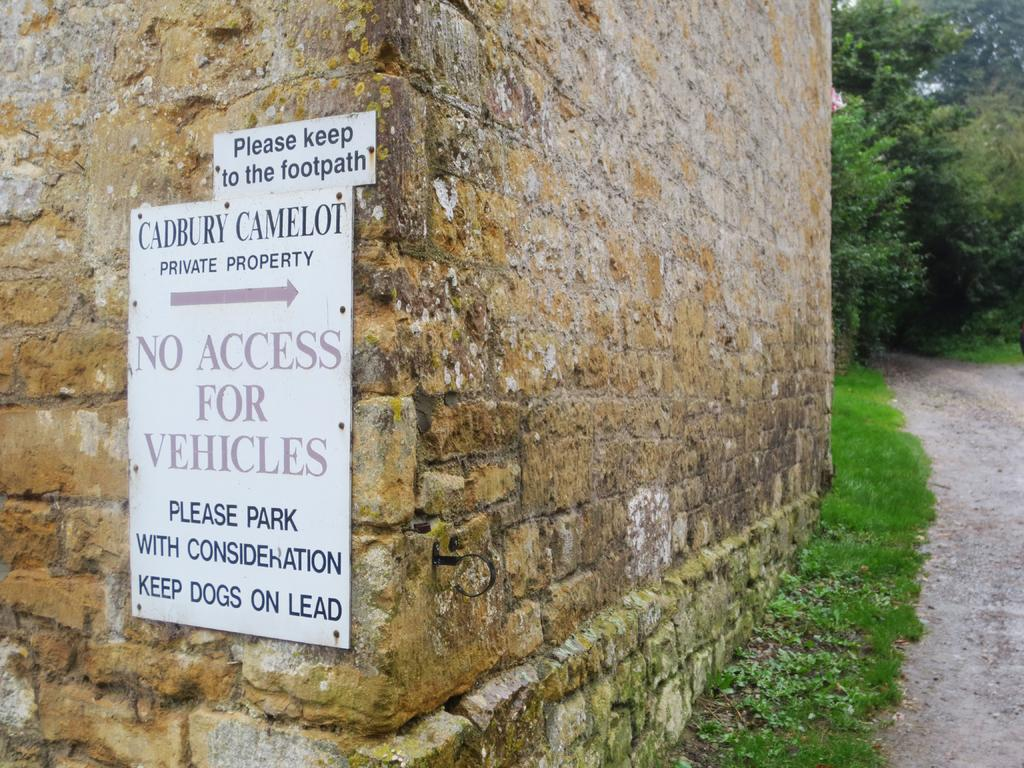What is present on the wall in the image? There is a board placed on the wall in the image. What can be seen on the right side of the image? There are trees on the right side of the image. What is located at the bottom of the image? There is a walkway at the bottom of the image. Can you see any wool in the image? There is no wool present in the image. How many toes are visible on the board in the image? There are no toes visible in the image, as it does not depict any feet or body parts. 